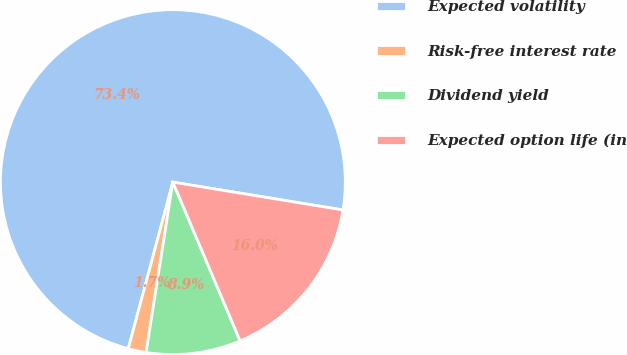<chart> <loc_0><loc_0><loc_500><loc_500><pie_chart><fcel>Expected volatility<fcel>Risk-free interest rate<fcel>Dividend yield<fcel>Expected option life (in<nl><fcel>73.42%<fcel>1.68%<fcel>8.86%<fcel>16.04%<nl></chart> 